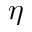<formula> <loc_0><loc_0><loc_500><loc_500>\eta</formula> 